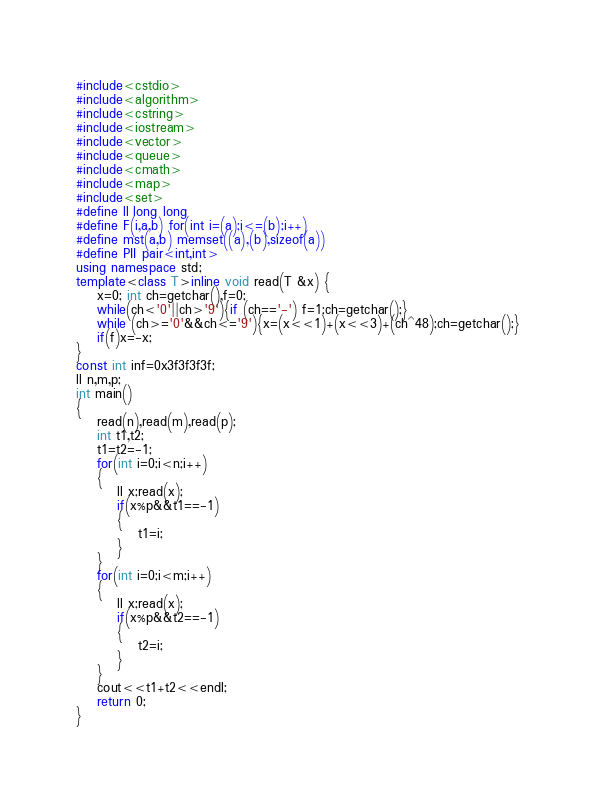Convert code to text. <code><loc_0><loc_0><loc_500><loc_500><_C++_>#include<cstdio>
#include<algorithm>
#include<cstring>
#include<iostream>
#include<vector>
#include<queue>
#include<cmath>
#include<map>
#include<set>
#define ll long long
#define F(i,a,b) for(int i=(a);i<=(b);i++)
#define mst(a,b) memset((a),(b),sizeof(a))
#define PII pair<int,int>
using namespace std;
template<class T>inline void read(T &x) {
    x=0; int ch=getchar(),f=0;
    while(ch<'0'||ch>'9'){if (ch=='-') f=1;ch=getchar();}
    while (ch>='0'&&ch<='9'){x=(x<<1)+(x<<3)+(ch^48);ch=getchar();}
    if(f)x=-x;
}
const int inf=0x3f3f3f3f;
ll n,m,p;
int main()
{
	read(n),read(m),read(p);
	int t1,t2;
	t1=t2=-1;
	for(int i=0;i<n;i++) 
	{
		ll x;read(x);
		if(x%p&&t1==-1)
		{
			t1=i;
		}
	}
	for(int i=0;i<m;i++) 
	{
		ll x;read(x);
		if(x%p&&t2==-1)
		{
			t2=i;
		}
	}
	cout<<t1+t2<<endl;
	return 0;
}

</code> 